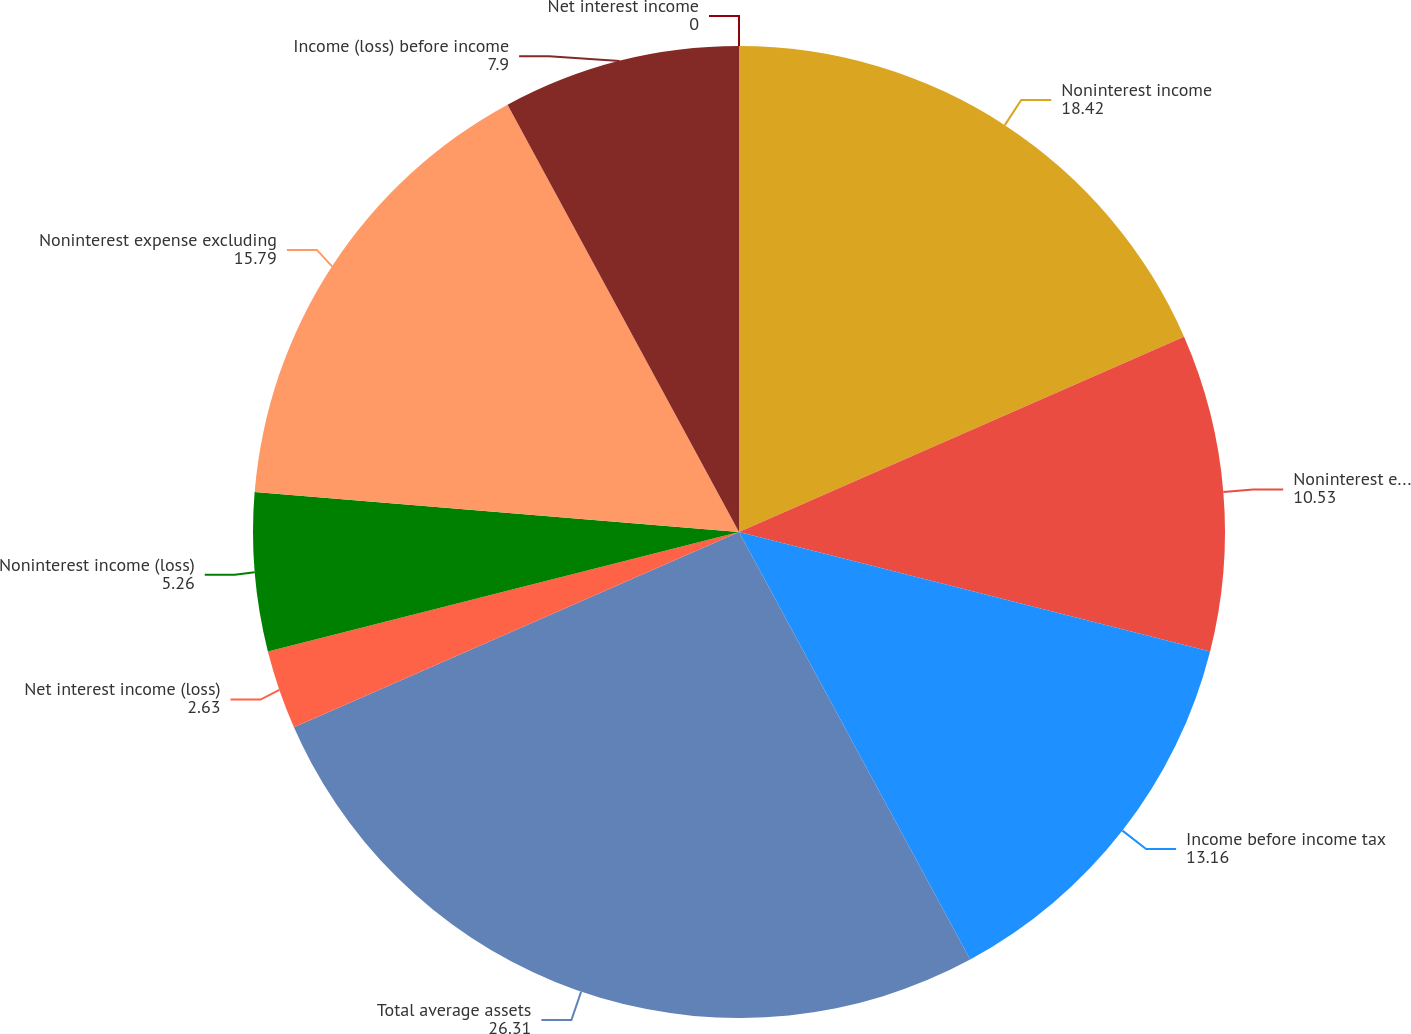Convert chart. <chart><loc_0><loc_0><loc_500><loc_500><pie_chart><fcel>Net interest income<fcel>Noninterest income<fcel>Noninterest expense (2)<fcel>Income before income tax<fcel>Total average assets<fcel>Net interest income (loss)<fcel>Noninterest income (loss)<fcel>Noninterest expense excluding<fcel>Income (loss) before income<nl><fcel>0.0%<fcel>18.42%<fcel>10.53%<fcel>13.16%<fcel>26.31%<fcel>2.63%<fcel>5.26%<fcel>15.79%<fcel>7.9%<nl></chart> 